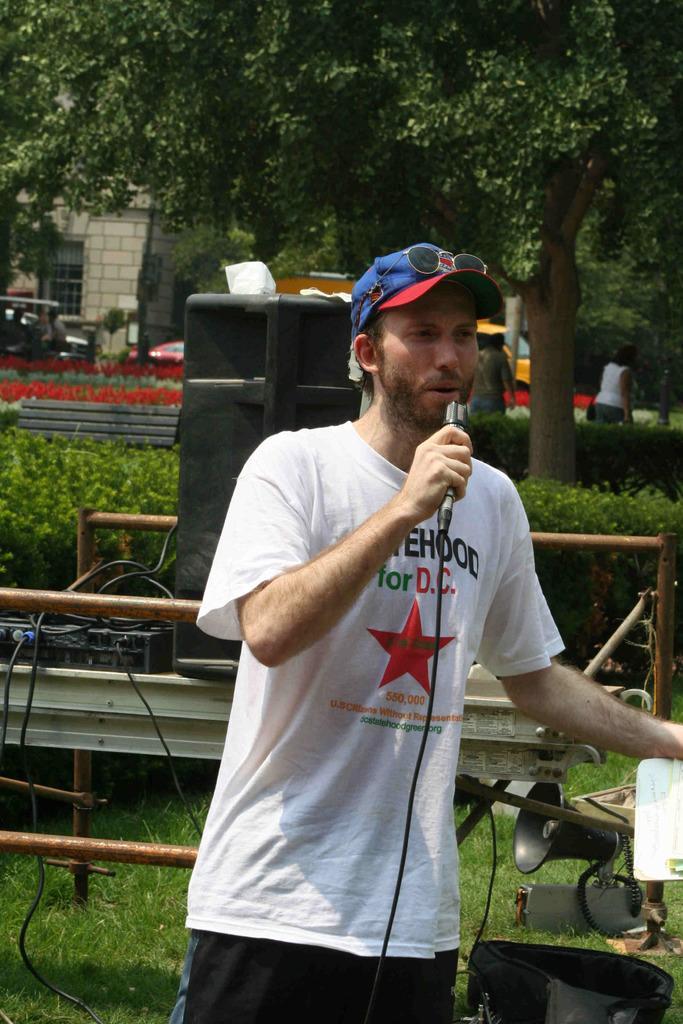Can you describe this image briefly? In this image we can see group of persons standing. One person is holding a microphone and a book in his hands. On the left side of the image we can see a speaker and a device with cables placed on the surface. In the right side of the image we can see a megaphone and a bag placed on the grass field. In the center of the image we can see some plants, a group of vehicles parked on the ground. At the top of the image we can see a building with windows and some trees. 